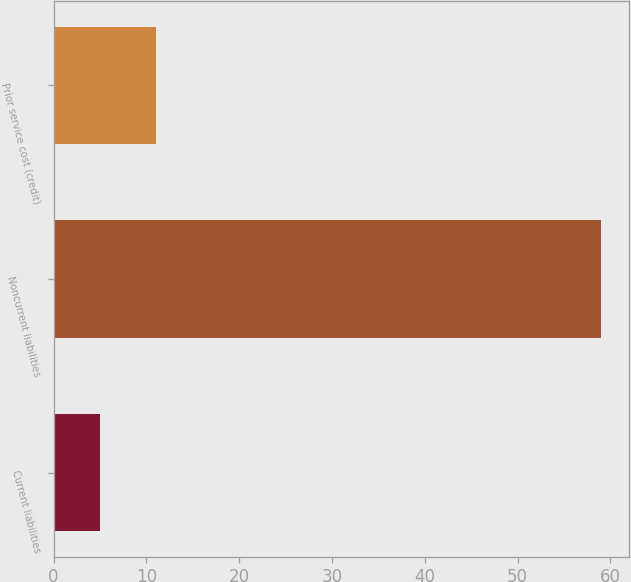Convert chart to OTSL. <chart><loc_0><loc_0><loc_500><loc_500><bar_chart><fcel>Current liabilities<fcel>Noncurrent liabilities<fcel>Prior service cost (credit)<nl><fcel>5<fcel>59<fcel>11<nl></chart> 